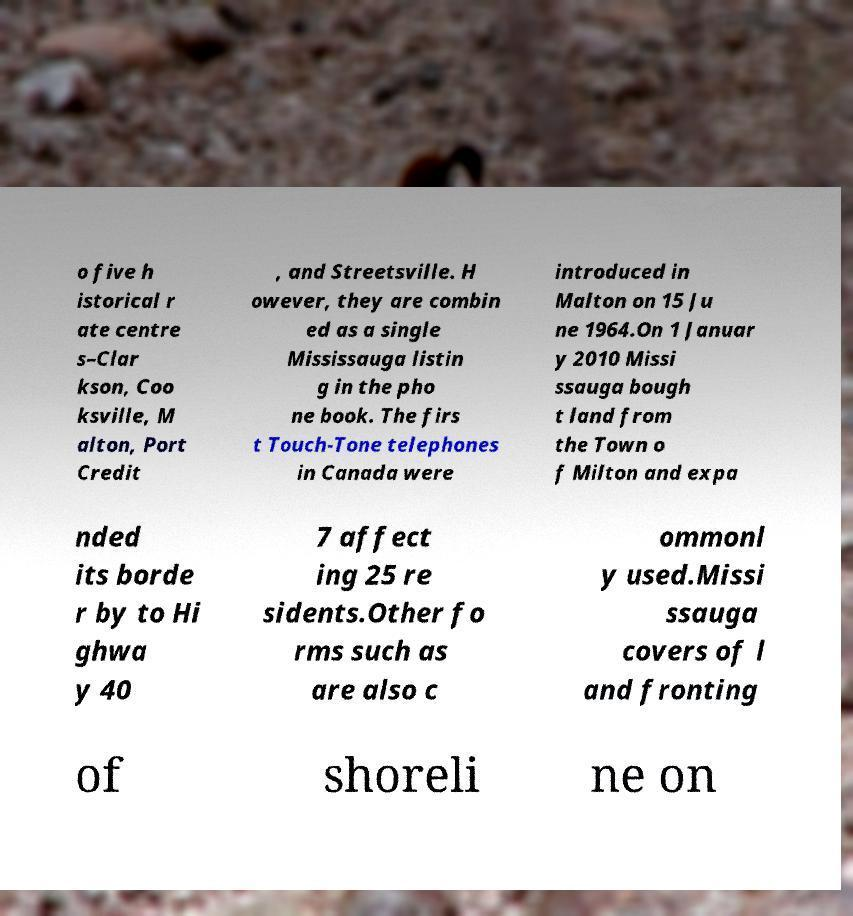Please identify and transcribe the text found in this image. o five h istorical r ate centre s–Clar kson, Coo ksville, M alton, Port Credit , and Streetsville. H owever, they are combin ed as a single Mississauga listin g in the pho ne book. The firs t Touch-Tone telephones in Canada were introduced in Malton on 15 Ju ne 1964.On 1 Januar y 2010 Missi ssauga bough t land from the Town o f Milton and expa nded its borde r by to Hi ghwa y 40 7 affect ing 25 re sidents.Other fo rms such as are also c ommonl y used.Missi ssauga covers of l and fronting of shoreli ne on 